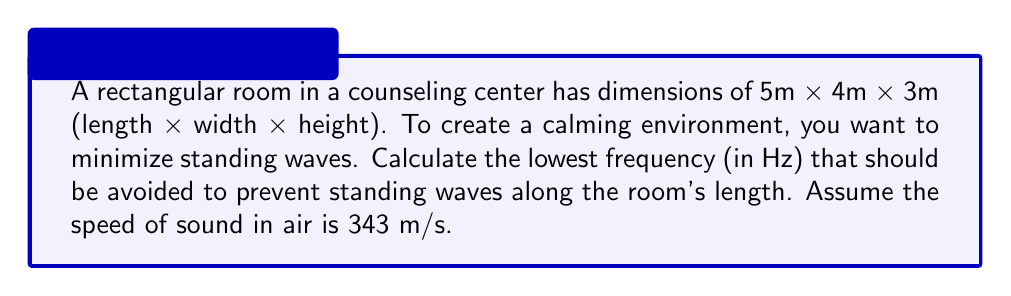Can you solve this math problem? To determine the lowest frequency that creates standing waves along the room's length, we need to use the wave equation for standing waves in one dimension:

$$f = \frac{v}{2L}$$

Where:
$f$ = frequency (Hz)
$v$ = speed of sound in air (343 m/s)
$L$ = length of the room (5 m)

Step 1: Identify the known values
$v = 343$ m/s
$L = 5$ m

Step 2: Substitute these values into the equation
$$f = \frac{343}{2(5)}$$

Step 3: Simplify and calculate
$$f = \frac{343}{10} = 34.3$$

Therefore, the lowest frequency that creates standing waves along the room's length is 34.3 Hz.

Understanding this concept can help in designing a calming environment by avoiding or minimizing sounds at this frequency and its harmonics, which could create uncomfortable resonances in the room.
Answer: 34.3 Hz 